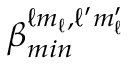Convert formula to latex. <formula><loc_0><loc_0><loc_500><loc_500>\beta _ { \min } ^ { \ell m _ { \ell } , \ell ^ { \prime } m _ { \ell } ^ { \prime } }</formula> 